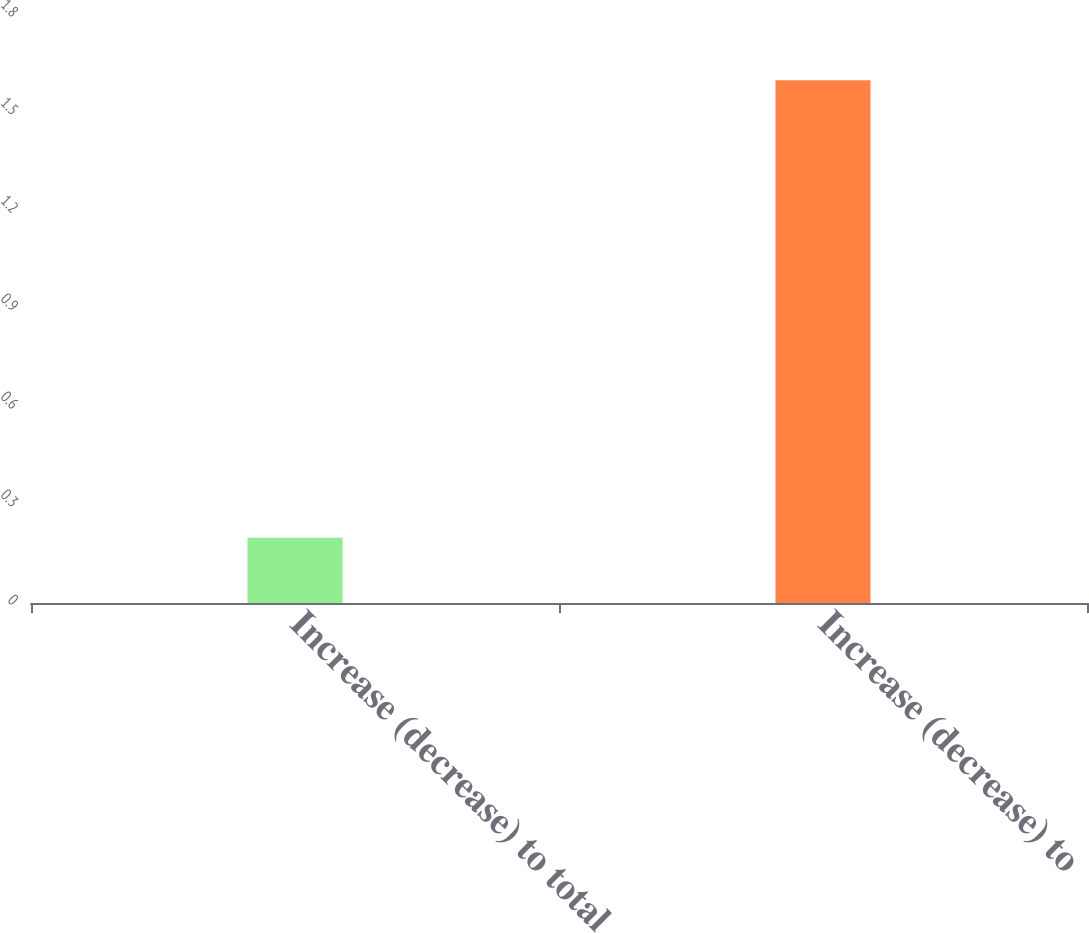Convert chart. <chart><loc_0><loc_0><loc_500><loc_500><bar_chart><fcel>Increase (decrease) to total<fcel>Increase (decrease) to<nl><fcel>0.2<fcel>1.6<nl></chart> 